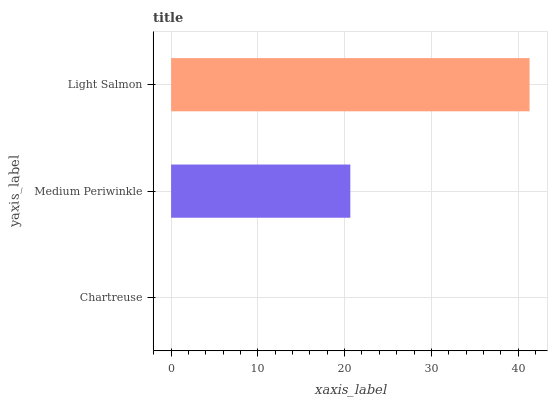Is Chartreuse the minimum?
Answer yes or no. Yes. Is Light Salmon the maximum?
Answer yes or no. Yes. Is Medium Periwinkle the minimum?
Answer yes or no. No. Is Medium Periwinkle the maximum?
Answer yes or no. No. Is Medium Periwinkle greater than Chartreuse?
Answer yes or no. Yes. Is Chartreuse less than Medium Periwinkle?
Answer yes or no. Yes. Is Chartreuse greater than Medium Periwinkle?
Answer yes or no. No. Is Medium Periwinkle less than Chartreuse?
Answer yes or no. No. Is Medium Periwinkle the high median?
Answer yes or no. Yes. Is Medium Periwinkle the low median?
Answer yes or no. Yes. Is Light Salmon the high median?
Answer yes or no. No. Is Light Salmon the low median?
Answer yes or no. No. 